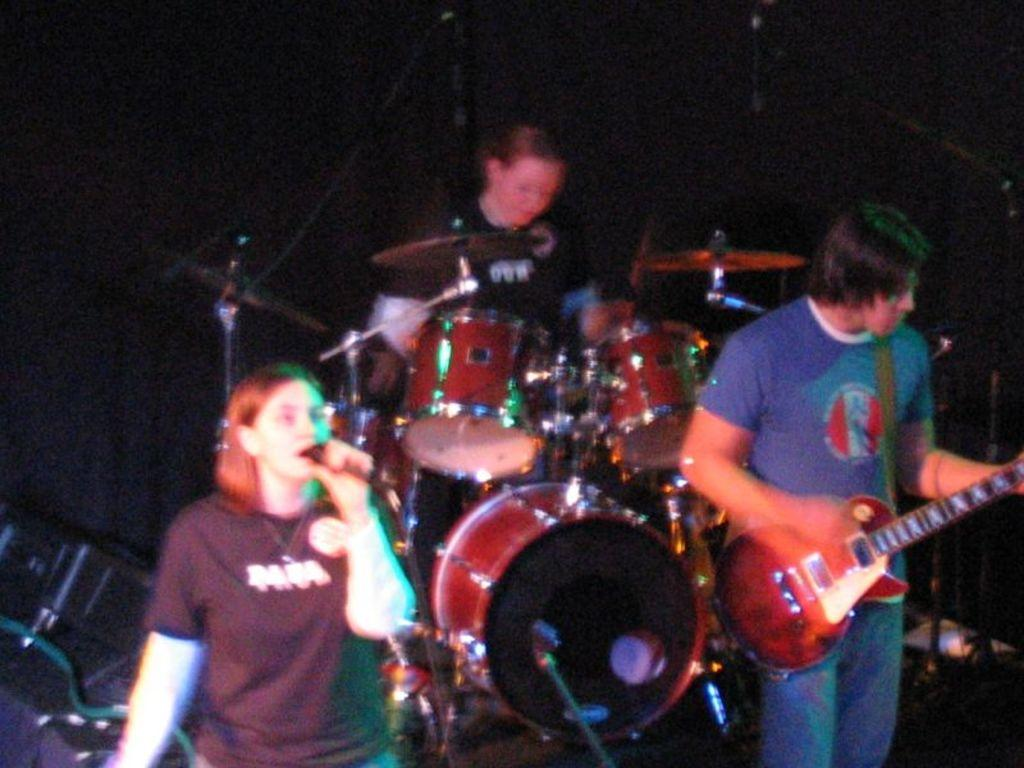How many people are in the image? There are three persons in the image. What is the woman holding in her hand? The woman is holding a mic in her hand. What instruments are being played by the other two persons? One person is playing drums, and the other person is playing guitar. What is the color of the background in the image? The background of the image is dark. Is there any smoke coming from the guitar in the image? There is no smoke visible in the image, and the guitar is not shown to be producing any smoke. 